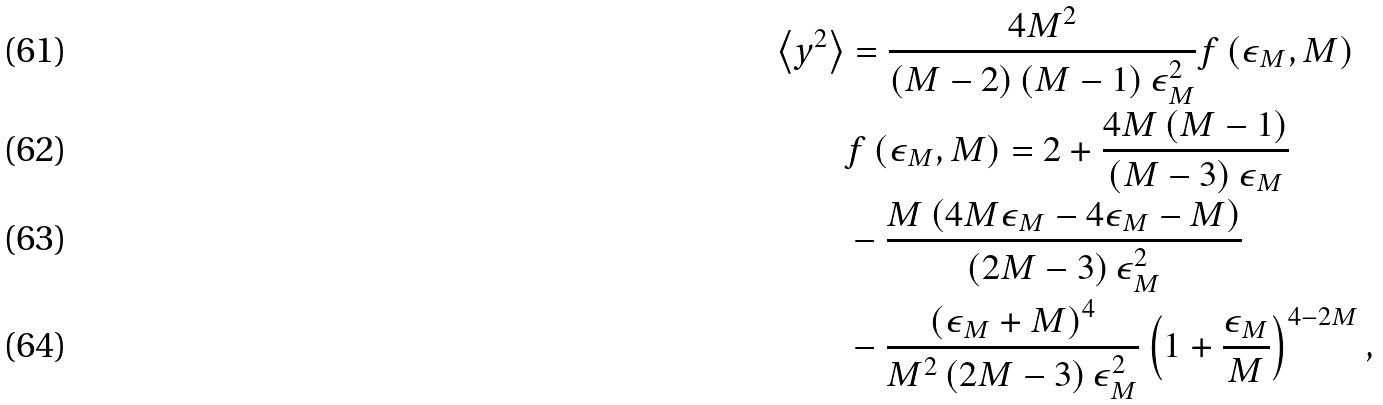<formula> <loc_0><loc_0><loc_500><loc_500>\left \langle y ^ { 2 } \right \rangle & = \frac { 4 M ^ { 2 } } { \left ( M - 2 \right ) \left ( M - 1 \right ) \epsilon _ { M } ^ { 2 } } f \left ( \epsilon _ { M } , M \right ) \\ & f \left ( \epsilon _ { M } , M \right ) = 2 + \frac { 4 M \left ( M - 1 \right ) } { \left ( M - 3 \right ) \epsilon _ { M } } \\ & - \frac { M \left ( 4 M \epsilon _ { M } - 4 \epsilon _ { M } - M \right ) } { \left ( 2 M - 3 \right ) \epsilon _ { M } ^ { 2 } } \\ & - \frac { \left ( \epsilon _ { M } + M \right ) ^ { 4 } } { M ^ { 2 } \left ( 2 M - 3 \right ) \epsilon _ { M } ^ { 2 } } \left ( 1 + \frac { \epsilon _ { M } } { M } \right ) ^ { 4 - 2 M } ,</formula> 